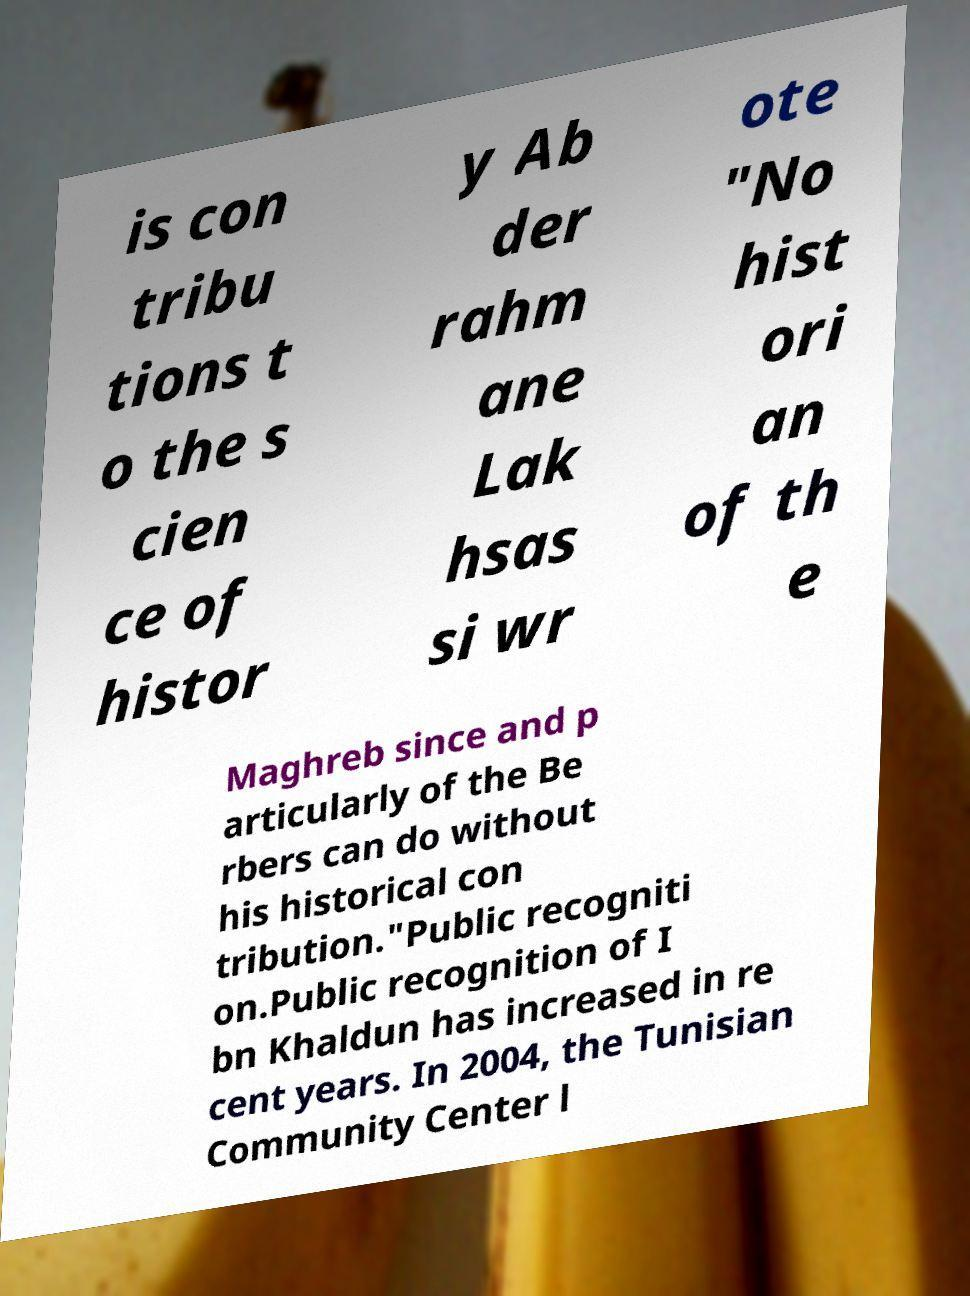Could you assist in decoding the text presented in this image and type it out clearly? is con tribu tions t o the s cien ce of histor y Ab der rahm ane Lak hsas si wr ote "No hist ori an of th e Maghreb since and p articularly of the Be rbers can do without his historical con tribution."Public recogniti on.Public recognition of I bn Khaldun has increased in re cent years. In 2004, the Tunisian Community Center l 